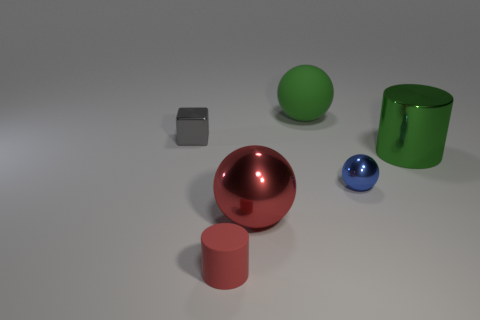Subtract all small spheres. How many spheres are left? 2 Add 2 tiny red shiny spheres. How many objects exist? 8 Subtract all red spheres. How many spheres are left? 2 Subtract all gray balls. Subtract all blue cylinders. How many balls are left? 3 Subtract all big things. Subtract all big green metallic objects. How many objects are left? 2 Add 2 small red rubber objects. How many small red rubber objects are left? 3 Add 5 tiny rubber cylinders. How many tiny rubber cylinders exist? 6 Subtract 1 green balls. How many objects are left? 5 Subtract all cubes. How many objects are left? 5 Subtract 1 spheres. How many spheres are left? 2 